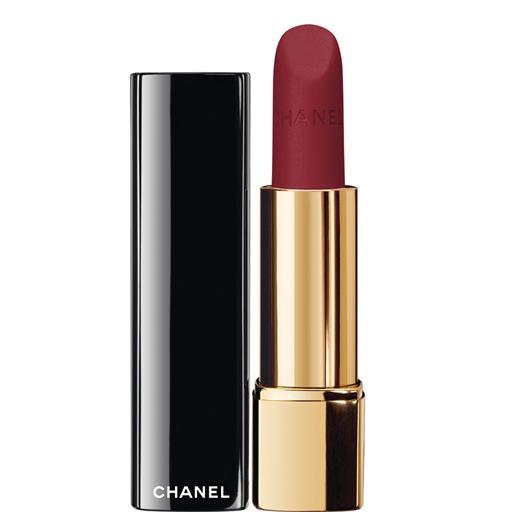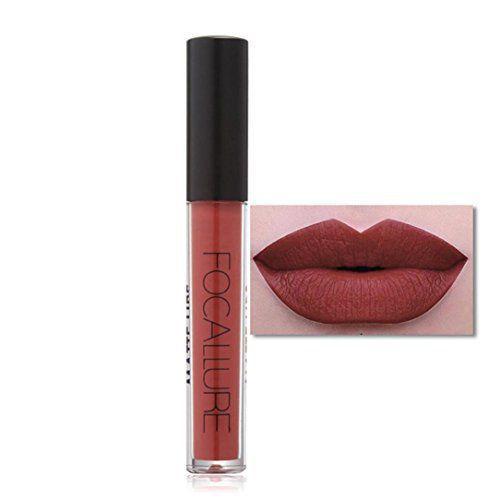The first image is the image on the left, the second image is the image on the right. Considering the images on both sides, is "Exactly two lipsticks are shown, one of them capped, but with a lip photo display, while the other is open with the lipstick extended." valid? Answer yes or no. Yes. The first image is the image on the left, the second image is the image on the right. Examine the images to the left and right. Is the description "An image shows one pair of painted lips to the right of a single lip makeup product." accurate? Answer yes or no. Yes. 